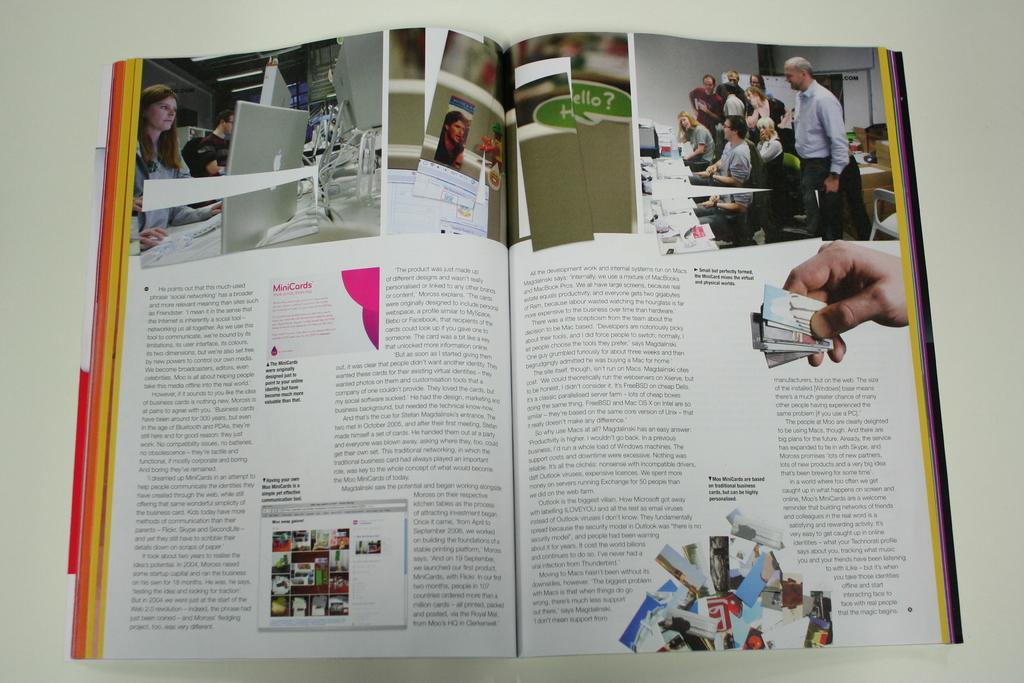Is there a picture that says "hello?"?
Provide a short and direct response. Yes. 